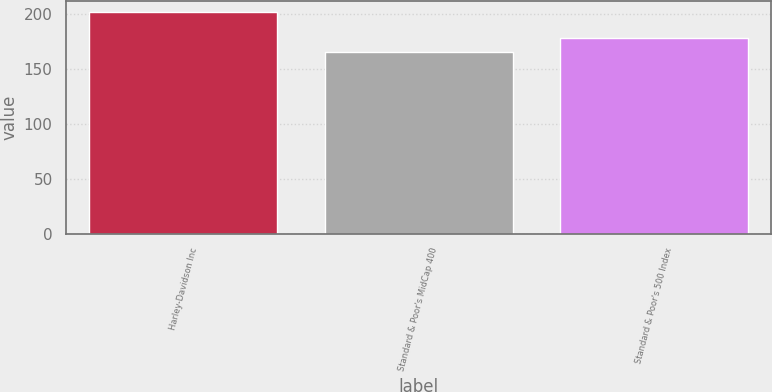<chart> <loc_0><loc_0><loc_500><loc_500><bar_chart><fcel>Harley-Davidson Inc<fcel>Standard & Poor's MidCap 400<fcel>Standard & Poor's 500 Index<nl><fcel>201<fcel>165<fcel>178<nl></chart> 